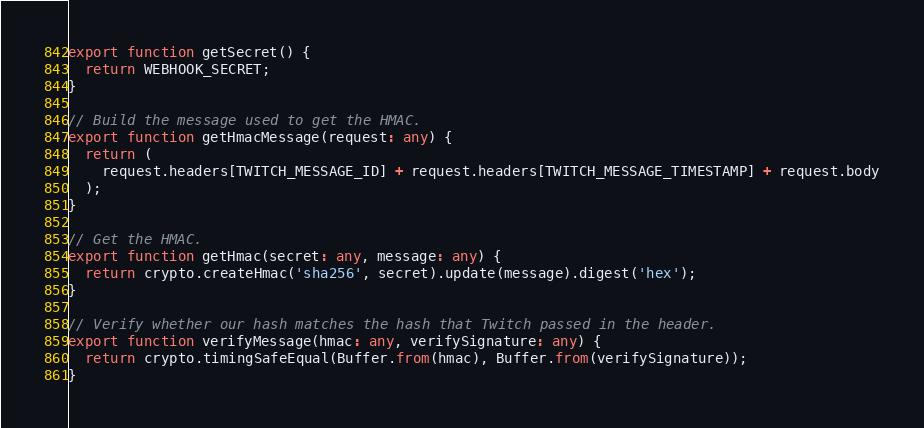<code> <loc_0><loc_0><loc_500><loc_500><_TypeScript_>
export function getSecret() {
  return WEBHOOK_SECRET;
}

// Build the message used to get the HMAC.
export function getHmacMessage(request: any) {
  return (
    request.headers[TWITCH_MESSAGE_ID] + request.headers[TWITCH_MESSAGE_TIMESTAMP] + request.body
  );
}

// Get the HMAC.
export function getHmac(secret: any, message: any) {
  return crypto.createHmac('sha256', secret).update(message).digest('hex');
}

// Verify whether our hash matches the hash that Twitch passed in the header.
export function verifyMessage(hmac: any, verifySignature: any) {
  return crypto.timingSafeEqual(Buffer.from(hmac), Buffer.from(verifySignature));
}
</code> 